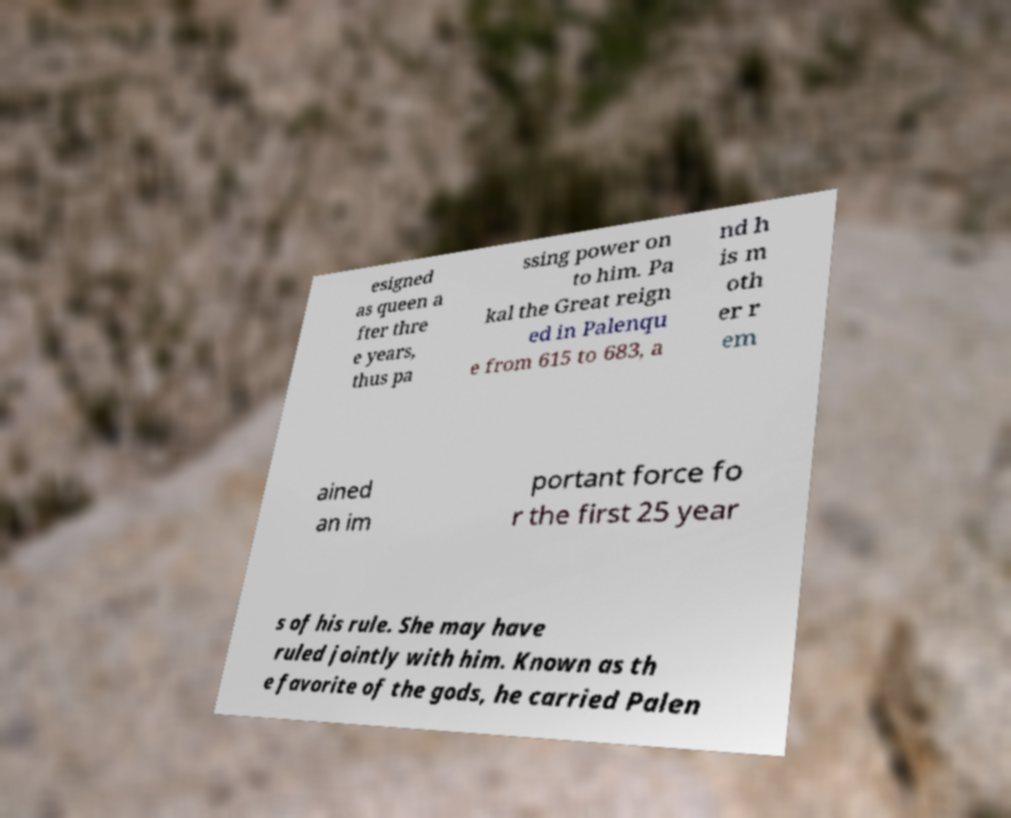What messages or text are displayed in this image? I need them in a readable, typed format. esigned as queen a fter thre e years, thus pa ssing power on to him. Pa kal the Great reign ed in Palenqu e from 615 to 683, a nd h is m oth er r em ained an im portant force fo r the first 25 year s of his rule. She may have ruled jointly with him. Known as th e favorite of the gods, he carried Palen 